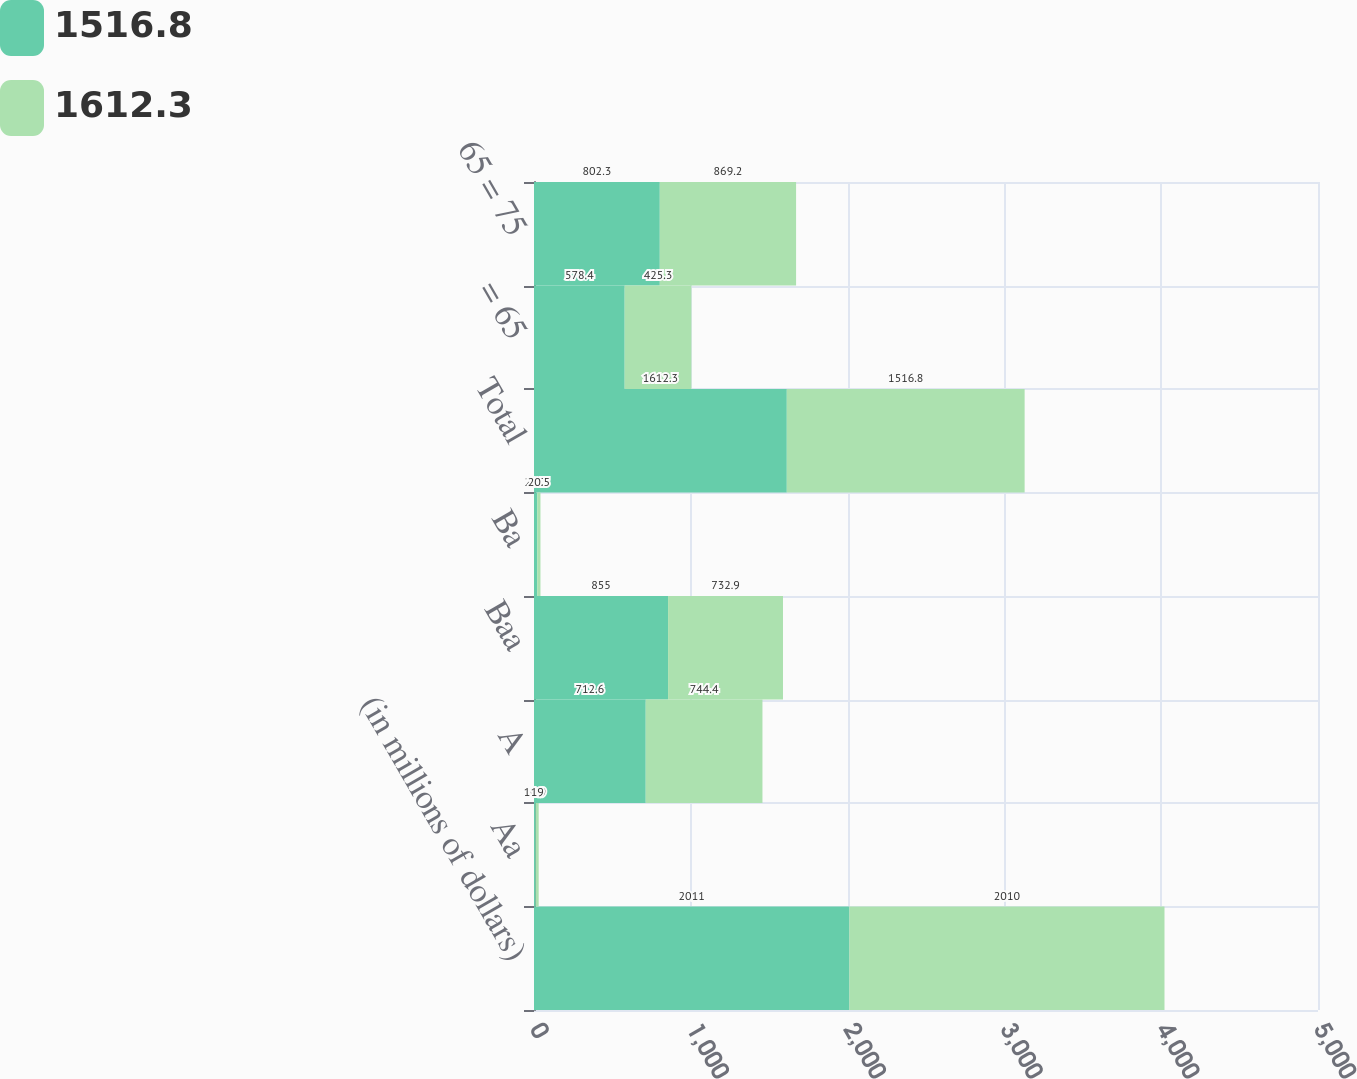<chart> <loc_0><loc_0><loc_500><loc_500><stacked_bar_chart><ecel><fcel>(in millions of dollars)<fcel>Aa<fcel>A<fcel>Baa<fcel>Ba<fcel>Total<fcel>= 65<fcel>65 = 75<nl><fcel>1516.8<fcel>2011<fcel>10.9<fcel>712.6<fcel>855<fcel>20.7<fcel>1612.3<fcel>578.4<fcel>802.3<nl><fcel>1612.3<fcel>2010<fcel>19<fcel>744.4<fcel>732.9<fcel>20.5<fcel>1516.8<fcel>425.3<fcel>869.2<nl></chart> 